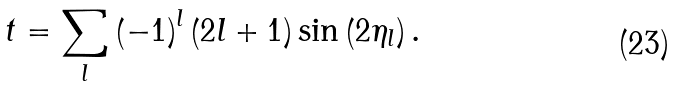Convert formula to latex. <formula><loc_0><loc_0><loc_500><loc_500>t = \sum _ { l } \left ( - 1 \right ) ^ { l } \left ( 2 l + 1 \right ) \sin \left ( 2 \eta _ { l } \right ) .</formula> 